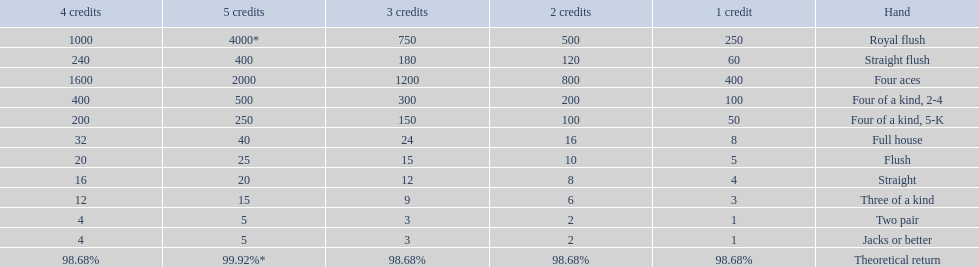What are the top 5 best types of hand for winning? Royal flush, Straight flush, Four aces, Four of a kind, 2-4, Four of a kind, 5-K. Between those 5, which of those hands are four of a kind? Four of a kind, 2-4, Four of a kind, 5-K. Of those 2 hands, which is the best kind of four of a kind for winning? Four of a kind, 2-4. 